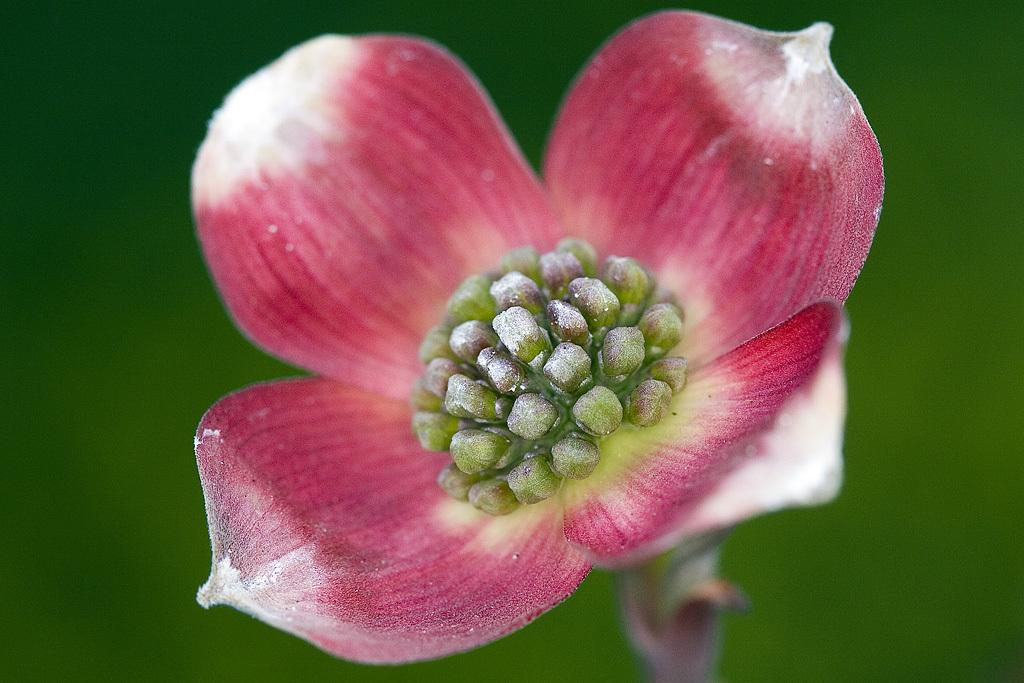What is the main subject of the image? The main subject of the image is a pink color flower. What color is the background of the image? The background of the image is green in color. What type of meal is being prepared in the image? There is no meal preparation visible in the image; it features a pink color flower with a green background. What is the educational background of the person who took the photo? The educational background of the person who took the photo is not mentioned or visible in the image. 